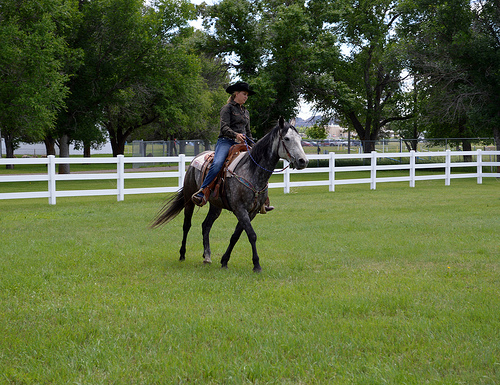<image>
Is there a horse on the fence? No. The horse is not positioned on the fence. They may be near each other, but the horse is not supported by or resting on top of the fence. 